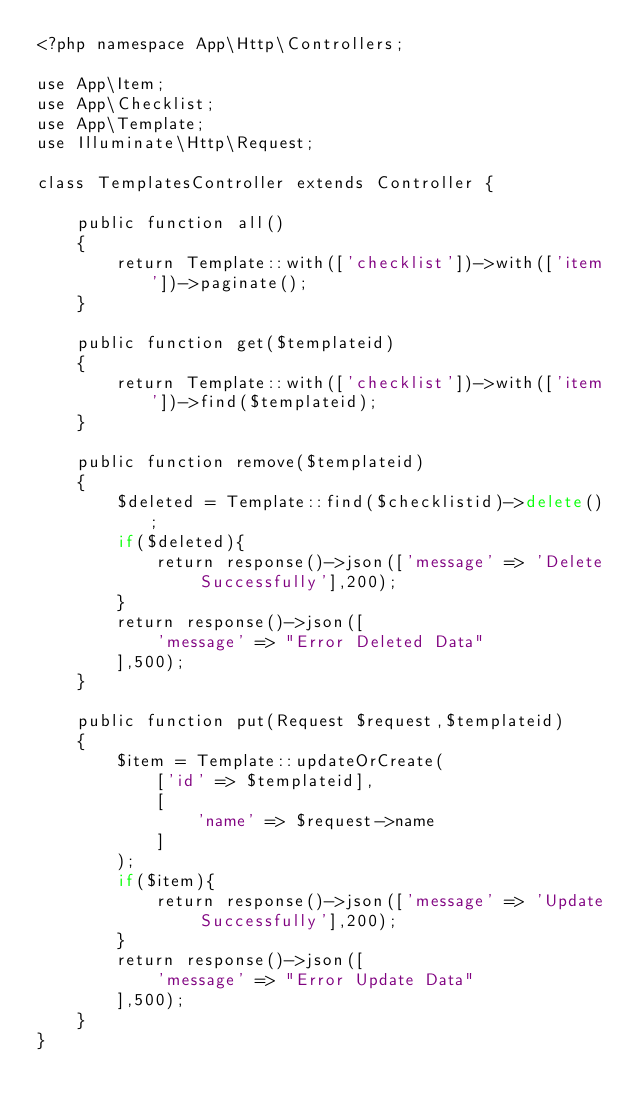Convert code to text. <code><loc_0><loc_0><loc_500><loc_500><_PHP_><?php namespace App\Http\Controllers;

use App\Item;
use App\Checklist;
use App\Template;
use Illuminate\Http\Request;

class TemplatesController extends Controller {

    public function all()
    {
        return Template::with(['checklist'])->with(['item'])->paginate();
    }

    public function get($templateid)
    {
        return Template::with(['checklist'])->with(['item'])->find($templateid);
    }

    public function remove($templateid)
    {
        $deleted = Template::find($checklistid)->delete();
        if($deleted){
            return response()->json(['message' => 'Delete Successfully'],200);
        }
        return response()->json([
            'message' => "Error Deleted Data"
        ],500);
    }

    public function put(Request $request,$templateid)
    {
        $item = Template::updateOrCreate(
            ['id' => $templateid],
            [
                'name' => $request->name
            ]
        );
        if($item){
            return response()->json(['message' => 'Update Successfully'],200);
        }
        return response()->json([
            'message' => "Error Update Data"
        ],500);
    }
}
</code> 